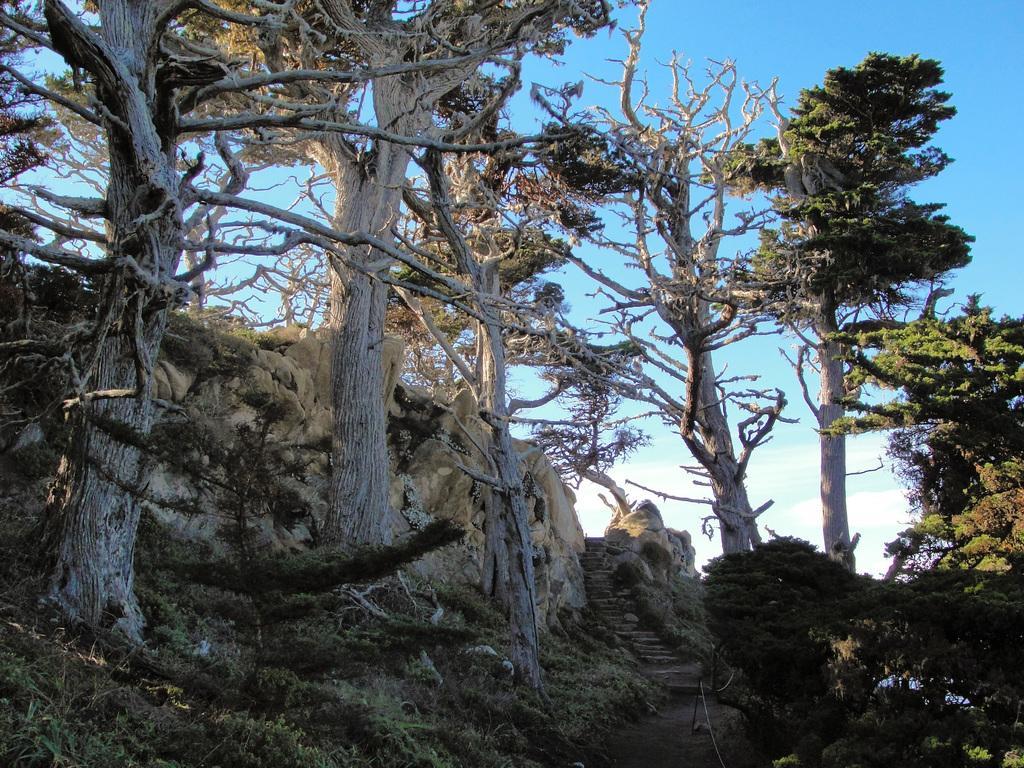Please provide a concise description of this image. This image consists of trees. There is sky at the top. There is grass at the bottom. 